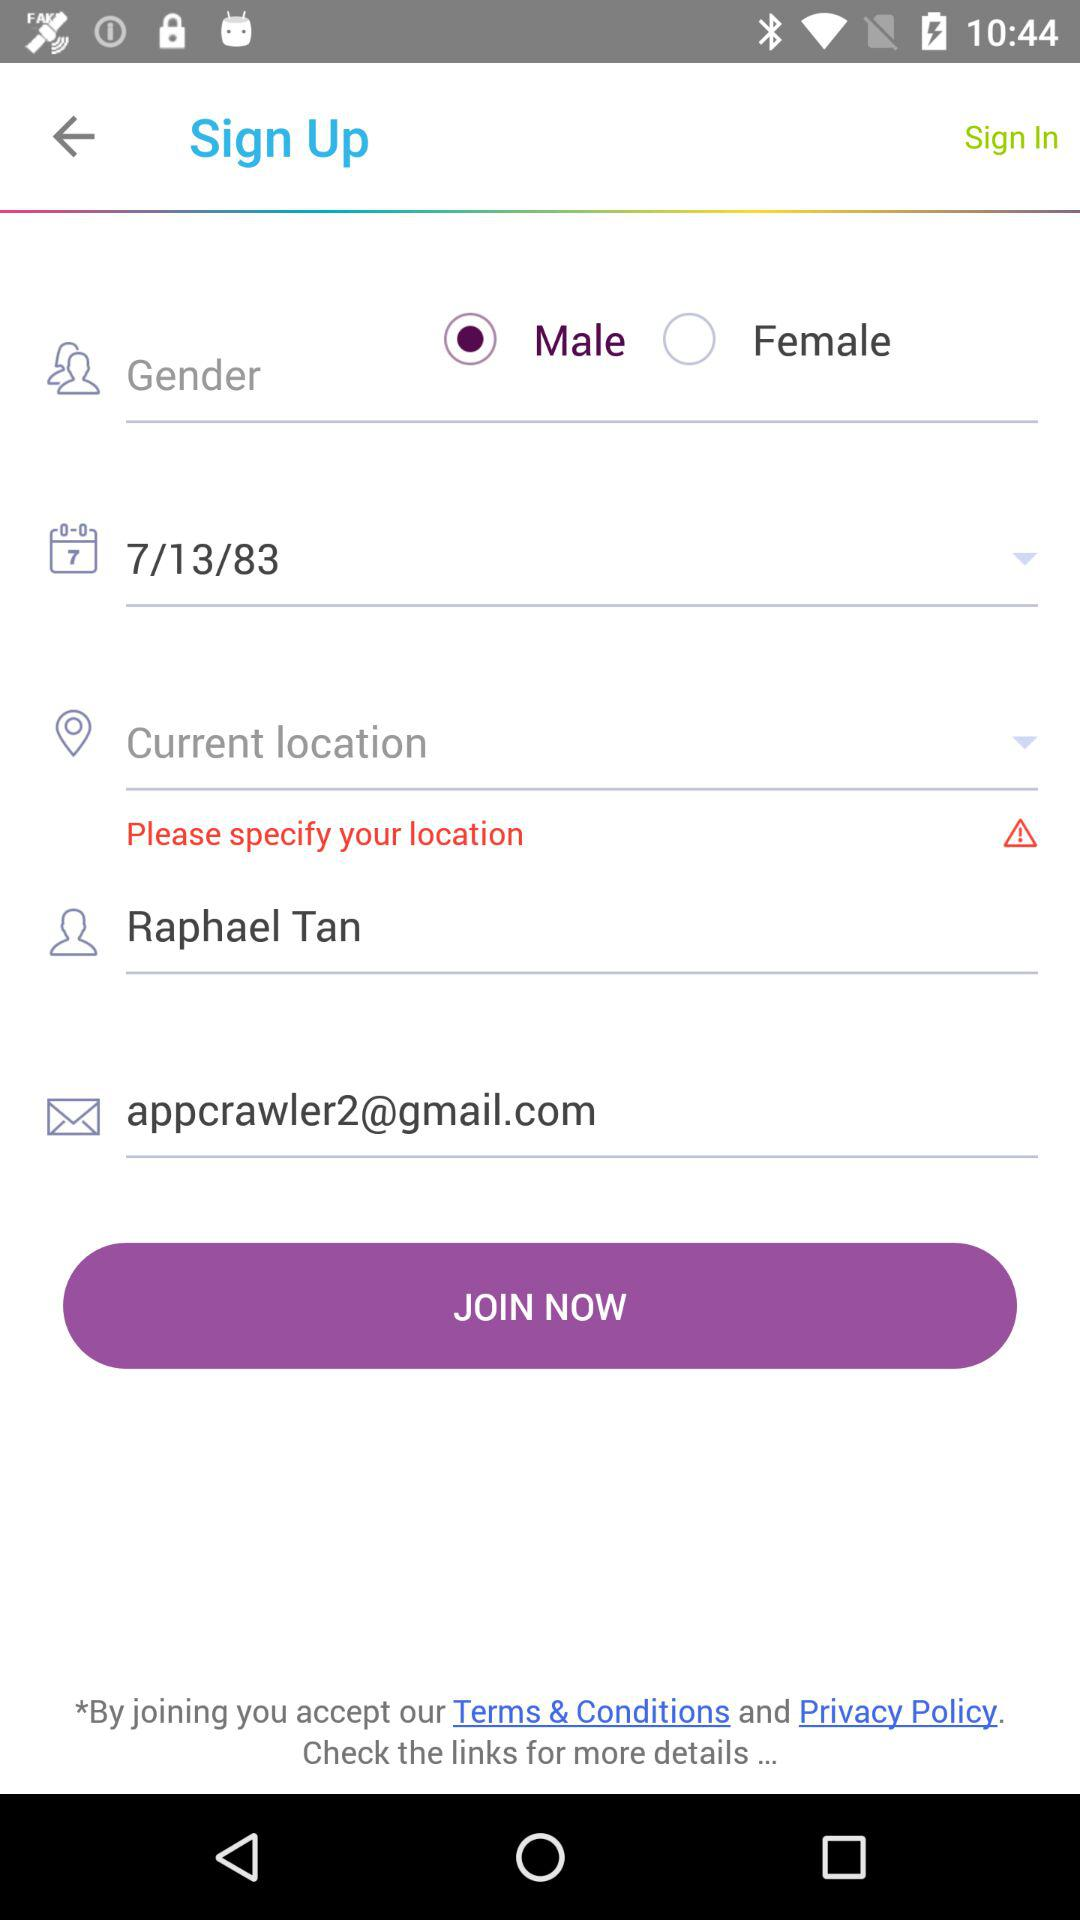What is the email address of the user? The email address of the user is appcrawler2@gmail.com. 